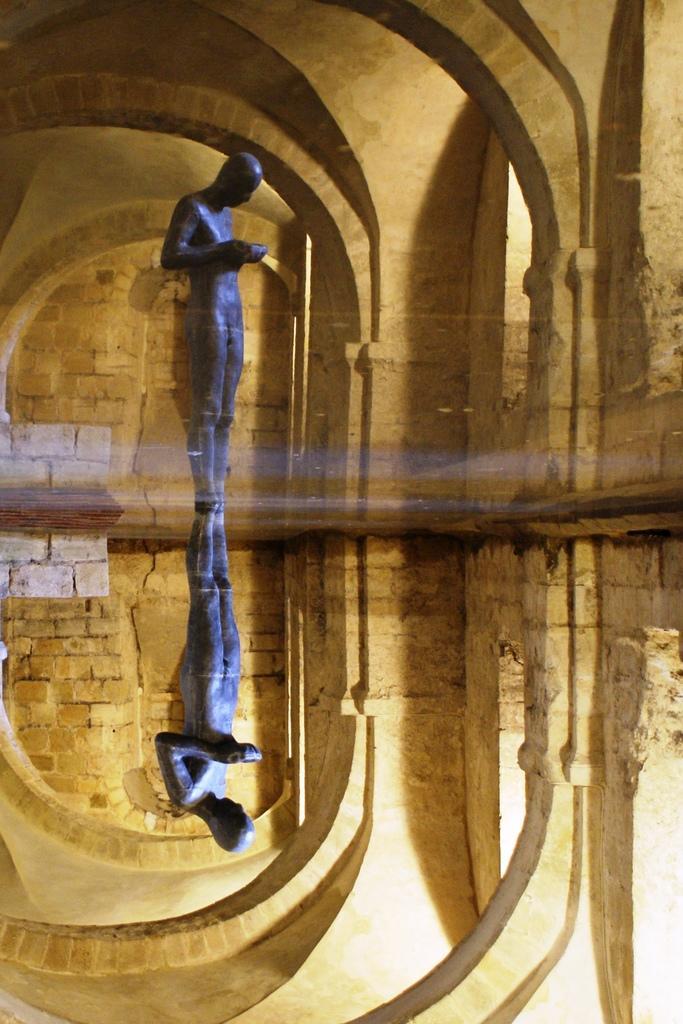Could you give a brief overview of what you see in this image? This image consists of a statue. It looks like edited. In the background, we can see a wall along with the pillars. It looks like an old fort. 